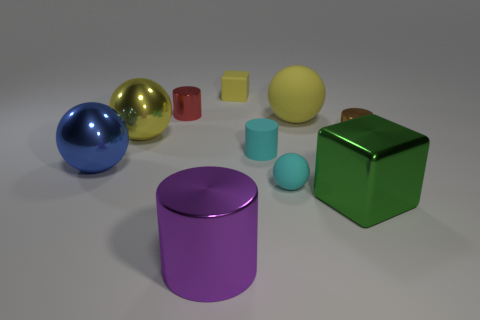There is a rubber sphere that is the same size as the yellow rubber cube; what color is it?
Your answer should be very brief. Cyan. Is there a large thing of the same color as the large cylinder?
Your answer should be very brief. No. What size is the red cylinder that is the same material as the big blue thing?
Ensure brevity in your answer.  Small. What is the size of the rubber block that is the same color as the big rubber sphere?
Provide a short and direct response. Small. How many other objects are there of the same size as the yellow shiny thing?
Your answer should be compact. 4. There is a cube on the right side of the small sphere; what is it made of?
Make the answer very short. Metal. There is a red shiny object behind the large yellow sphere that is behind the yellow thing that is left of the tiny yellow block; what is its shape?
Keep it short and to the point. Cylinder. Is the size of the cyan ball the same as the green metallic object?
Keep it short and to the point. No. How many things are either big yellow metal cubes or tiny shiny cylinders that are behind the large cube?
Your answer should be compact. 2. What number of things are either cubes in front of the brown thing or blocks right of the small cyan cylinder?
Offer a terse response. 1. 